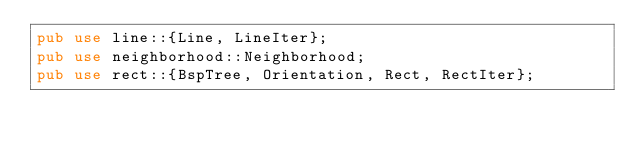Convert code to text. <code><loc_0><loc_0><loc_500><loc_500><_Rust_>pub use line::{Line, LineIter};
pub use neighborhood::Neighborhood;
pub use rect::{BspTree, Orientation, Rect, RectIter};
</code> 